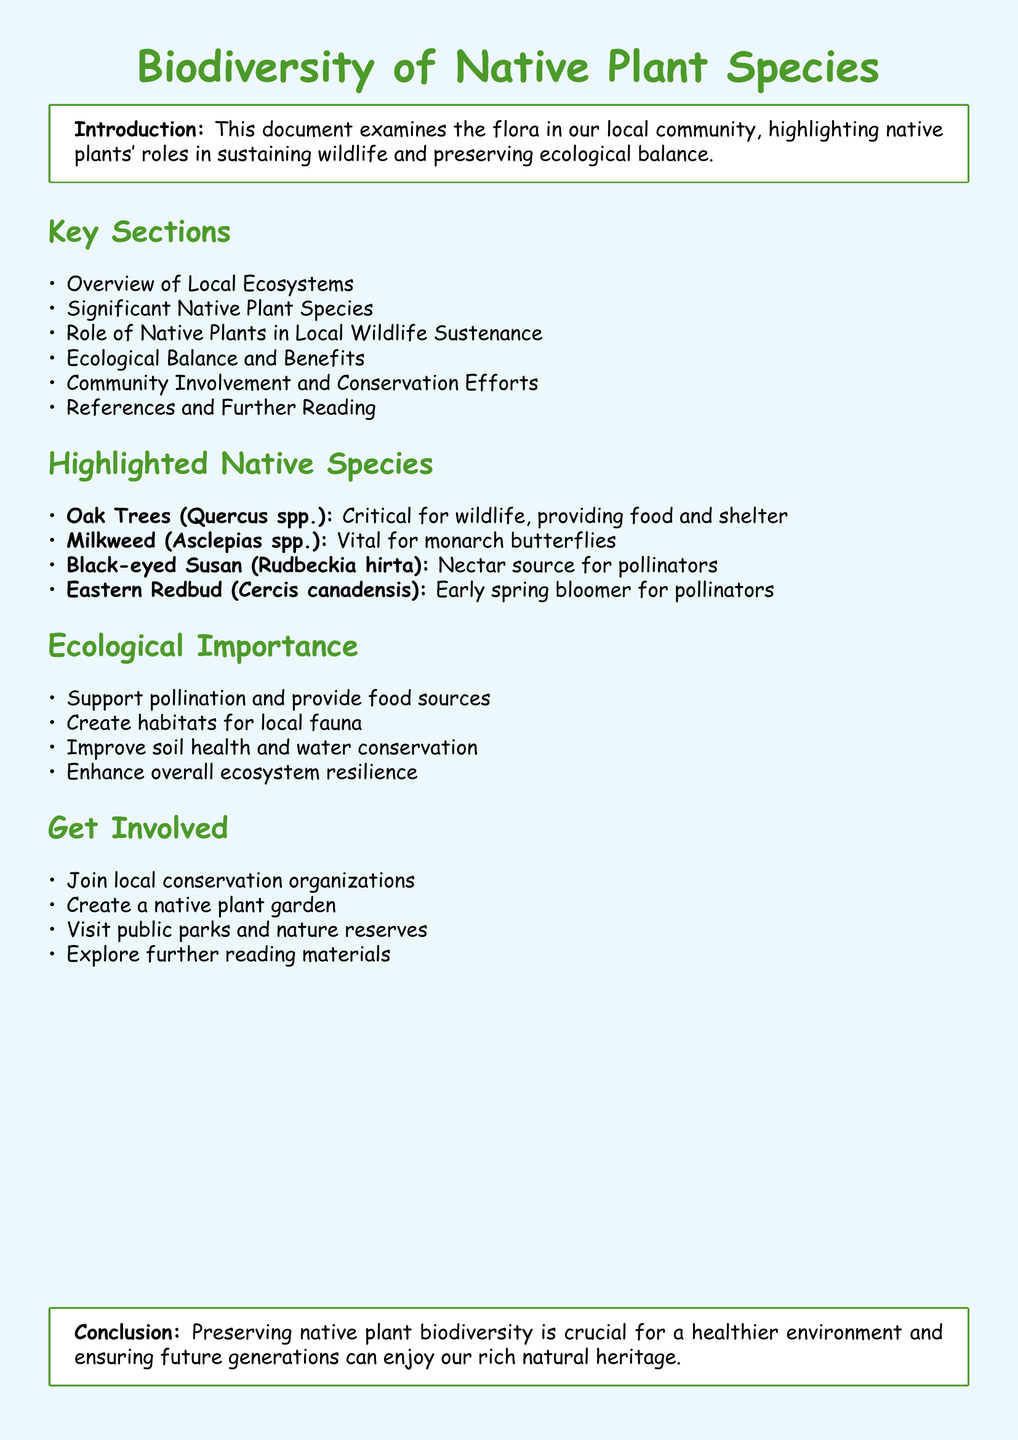What is the title of the document? The title is presented prominently at the beginning of the document.
Answer: Biodiversity of Native Plant Species How many significant native plant species are highlighted? The document lists four specific species under the highlighted section.
Answer: Four What is the role of native plants mentioned in the ecological importance section? This section outlines multiple contributions of native plants to the ecosystem, including providing food sources.
Answer: Support pollination What community involvement activity is suggested? The document provides suggestions in the get involved section, mentioning creating gardens.
Answer: Create a native plant garden Which species is vital for monarch butterflies? The document specifically identifies the plant that supports this butterfly species.
Answer: Milkweed 